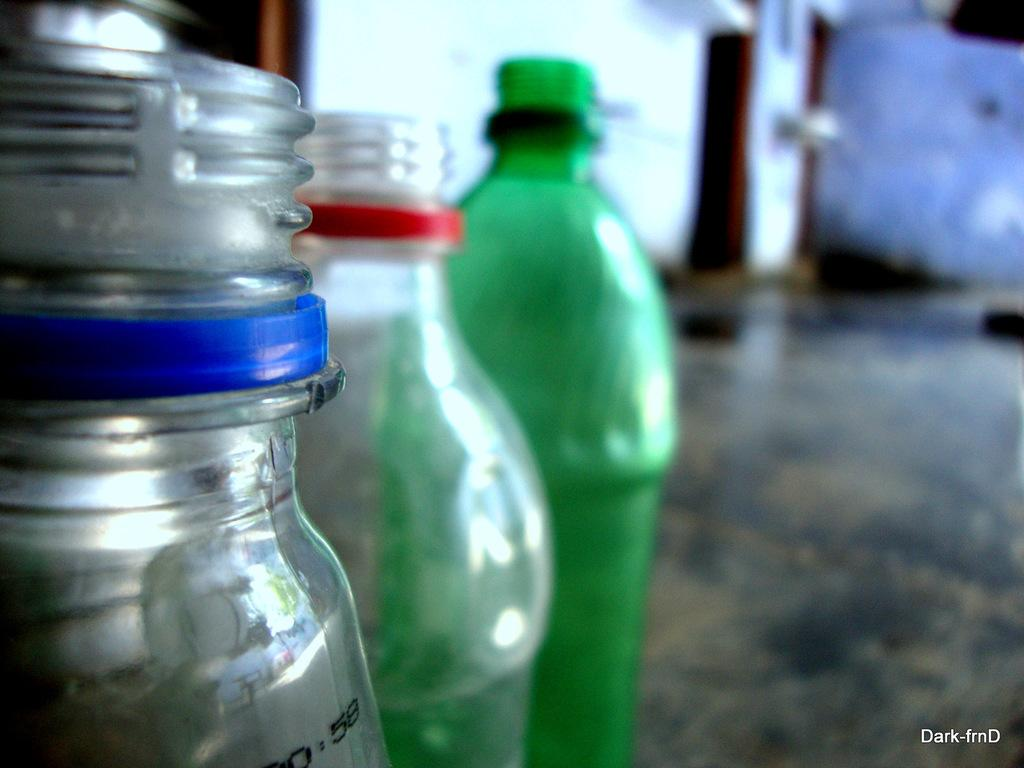How many bottles are visible in the image? There are three bottles in the image. What can be seen in the background of the image? There is a wall in the background of the image. What type of hate can be observed in the image? There is no hate present in the image; it features three bottles and a wall in the background. How many legs are visible in the image? There are no legs visible in the image; it features three bottles and a wall in the background. 